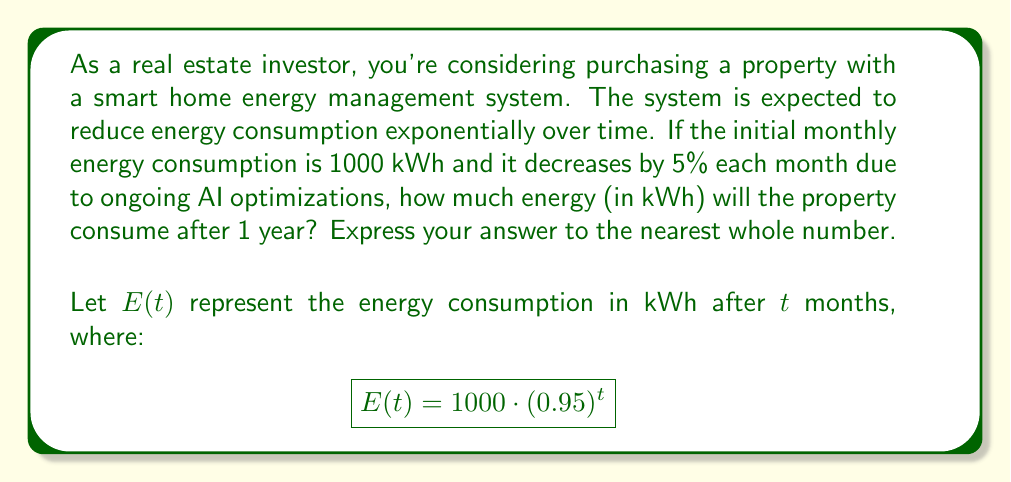Help me with this question. To solve this problem, we need to use the given exponential function and calculate the energy consumption after 12 months (1 year). Let's break it down step-by-step:

1) We're given the exponential function:
   $$E(t) = 1000 \cdot (0.95)^t$$

   Where:
   - 1000 is the initial energy consumption in kWh
   - 0.95 represents the 5% decrease each month (1 - 0.05 = 0.95)
   - $t$ is the number of months

2) We want to find $E(12)$ since we're looking at the consumption after 1 year (12 months):
   $$E(12) = 1000 \cdot (0.95)^{12}$$

3) Let's calculate this:
   $$E(12) = 1000 \cdot (0.95)^{12}$$
   $$= 1000 \cdot 0.5400916$$
   $$= 540.0916 \text{ kWh}$$

4) Rounding to the nearest whole number:
   540.0916 ≈ 540 kWh

Therefore, after 1 year, the property will consume approximately 540 kWh of energy per month.
Answer: 540 kWh 